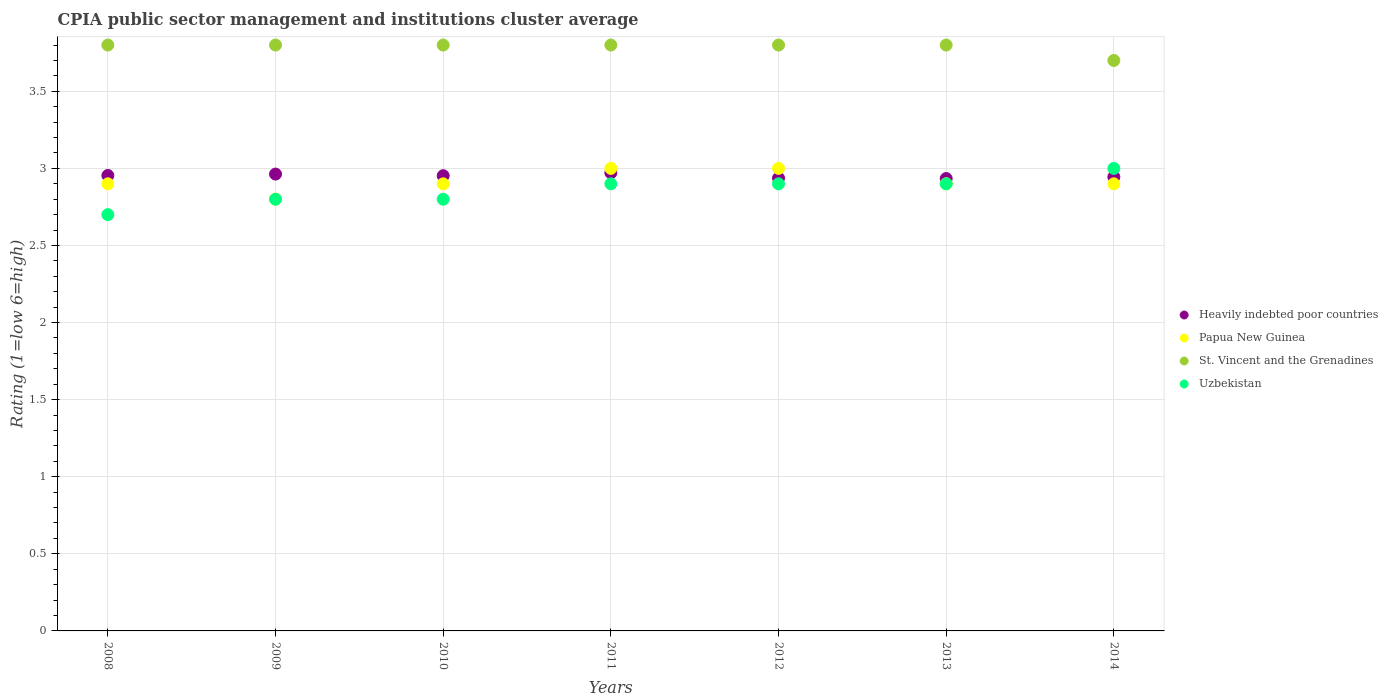Is the number of dotlines equal to the number of legend labels?
Keep it short and to the point. Yes. Across all years, what is the maximum CPIA rating in Heavily indebted poor countries?
Give a very brief answer. 2.97. In which year was the CPIA rating in St. Vincent and the Grenadines minimum?
Provide a short and direct response. 2014. What is the total CPIA rating in Heavily indebted poor countries in the graph?
Make the answer very short. 20.66. What is the difference between the CPIA rating in Heavily indebted poor countries in 2008 and that in 2012?
Provide a succinct answer. 0.02. What is the difference between the CPIA rating in St. Vincent and the Grenadines in 2013 and the CPIA rating in Uzbekistan in 2014?
Offer a very short reply. 0.8. What is the average CPIA rating in Heavily indebted poor countries per year?
Keep it short and to the point. 2.95. In the year 2010, what is the difference between the CPIA rating in Papua New Guinea and CPIA rating in St. Vincent and the Grenadines?
Keep it short and to the point. -0.9. In how many years, is the CPIA rating in Papua New Guinea greater than 2.6?
Offer a terse response. 7. What is the difference between the highest and the second highest CPIA rating in Uzbekistan?
Provide a succinct answer. 0.1. What is the difference between the highest and the lowest CPIA rating in Uzbekistan?
Your answer should be compact. 0.3. In how many years, is the CPIA rating in Heavily indebted poor countries greater than the average CPIA rating in Heavily indebted poor countries taken over all years?
Provide a succinct answer. 4. Is the sum of the CPIA rating in Papua New Guinea in 2008 and 2012 greater than the maximum CPIA rating in Heavily indebted poor countries across all years?
Your answer should be compact. Yes. Is it the case that in every year, the sum of the CPIA rating in Papua New Guinea and CPIA rating in Uzbekistan  is greater than the sum of CPIA rating in Heavily indebted poor countries and CPIA rating in St. Vincent and the Grenadines?
Give a very brief answer. No. Is it the case that in every year, the sum of the CPIA rating in Heavily indebted poor countries and CPIA rating in St. Vincent and the Grenadines  is greater than the CPIA rating in Papua New Guinea?
Your answer should be very brief. Yes. Does the CPIA rating in St. Vincent and the Grenadines monotonically increase over the years?
Provide a succinct answer. No. Is the CPIA rating in Uzbekistan strictly greater than the CPIA rating in St. Vincent and the Grenadines over the years?
Provide a succinct answer. No. What is the difference between two consecutive major ticks on the Y-axis?
Provide a short and direct response. 0.5. Does the graph contain any zero values?
Ensure brevity in your answer.  No. Does the graph contain grids?
Your answer should be very brief. Yes. Where does the legend appear in the graph?
Offer a terse response. Center right. What is the title of the graph?
Your answer should be compact. CPIA public sector management and institutions cluster average. What is the label or title of the X-axis?
Your response must be concise. Years. What is the label or title of the Y-axis?
Keep it short and to the point. Rating (1=low 6=high). What is the Rating (1=low 6=high) in Heavily indebted poor countries in 2008?
Keep it short and to the point. 2.95. What is the Rating (1=low 6=high) in Papua New Guinea in 2008?
Make the answer very short. 2.9. What is the Rating (1=low 6=high) of St. Vincent and the Grenadines in 2008?
Offer a terse response. 3.8. What is the Rating (1=low 6=high) in Heavily indebted poor countries in 2009?
Your answer should be compact. 2.96. What is the Rating (1=low 6=high) of Papua New Guinea in 2009?
Your response must be concise. 2.8. What is the Rating (1=low 6=high) in Uzbekistan in 2009?
Give a very brief answer. 2.8. What is the Rating (1=low 6=high) in Heavily indebted poor countries in 2010?
Offer a very short reply. 2.95. What is the Rating (1=low 6=high) in Papua New Guinea in 2010?
Your response must be concise. 2.9. What is the Rating (1=low 6=high) of St. Vincent and the Grenadines in 2010?
Make the answer very short. 3.8. What is the Rating (1=low 6=high) in Uzbekistan in 2010?
Ensure brevity in your answer.  2.8. What is the Rating (1=low 6=high) in Heavily indebted poor countries in 2011?
Your answer should be compact. 2.97. What is the Rating (1=low 6=high) in Papua New Guinea in 2011?
Keep it short and to the point. 3. What is the Rating (1=low 6=high) of St. Vincent and the Grenadines in 2011?
Make the answer very short. 3.8. What is the Rating (1=low 6=high) of Uzbekistan in 2011?
Offer a terse response. 2.9. What is the Rating (1=low 6=high) of Heavily indebted poor countries in 2012?
Provide a short and direct response. 2.94. What is the Rating (1=low 6=high) in Papua New Guinea in 2012?
Ensure brevity in your answer.  3. What is the Rating (1=low 6=high) of St. Vincent and the Grenadines in 2012?
Your answer should be compact. 3.8. What is the Rating (1=low 6=high) in Heavily indebted poor countries in 2013?
Keep it short and to the point. 2.93. What is the Rating (1=low 6=high) of Heavily indebted poor countries in 2014?
Your response must be concise. 2.94. What is the Rating (1=low 6=high) of Papua New Guinea in 2014?
Ensure brevity in your answer.  2.9. Across all years, what is the maximum Rating (1=low 6=high) of Heavily indebted poor countries?
Your response must be concise. 2.97. Across all years, what is the maximum Rating (1=low 6=high) in St. Vincent and the Grenadines?
Ensure brevity in your answer.  3.8. Across all years, what is the maximum Rating (1=low 6=high) of Uzbekistan?
Offer a very short reply. 3. Across all years, what is the minimum Rating (1=low 6=high) of Heavily indebted poor countries?
Provide a succinct answer. 2.93. Across all years, what is the minimum Rating (1=low 6=high) of St. Vincent and the Grenadines?
Provide a short and direct response. 3.7. Across all years, what is the minimum Rating (1=low 6=high) of Uzbekistan?
Your response must be concise. 2.7. What is the total Rating (1=low 6=high) of Heavily indebted poor countries in the graph?
Your answer should be very brief. 20.66. What is the total Rating (1=low 6=high) in Papua New Guinea in the graph?
Give a very brief answer. 20.4. What is the difference between the Rating (1=low 6=high) in Heavily indebted poor countries in 2008 and that in 2009?
Make the answer very short. -0.01. What is the difference between the Rating (1=low 6=high) of St. Vincent and the Grenadines in 2008 and that in 2009?
Your answer should be very brief. 0. What is the difference between the Rating (1=low 6=high) of Uzbekistan in 2008 and that in 2009?
Provide a short and direct response. -0.1. What is the difference between the Rating (1=low 6=high) of Heavily indebted poor countries in 2008 and that in 2010?
Offer a very short reply. 0. What is the difference between the Rating (1=low 6=high) of Papua New Guinea in 2008 and that in 2010?
Provide a short and direct response. 0. What is the difference between the Rating (1=low 6=high) in Heavily indebted poor countries in 2008 and that in 2011?
Provide a succinct answer. -0.02. What is the difference between the Rating (1=low 6=high) of St. Vincent and the Grenadines in 2008 and that in 2011?
Your answer should be very brief. 0. What is the difference between the Rating (1=low 6=high) of Uzbekistan in 2008 and that in 2011?
Ensure brevity in your answer.  -0.2. What is the difference between the Rating (1=low 6=high) in Heavily indebted poor countries in 2008 and that in 2012?
Your answer should be very brief. 0.02. What is the difference between the Rating (1=low 6=high) of Uzbekistan in 2008 and that in 2012?
Keep it short and to the point. -0.2. What is the difference between the Rating (1=low 6=high) of Heavily indebted poor countries in 2008 and that in 2013?
Your answer should be very brief. 0.02. What is the difference between the Rating (1=low 6=high) of Heavily indebted poor countries in 2008 and that in 2014?
Offer a very short reply. 0.01. What is the difference between the Rating (1=low 6=high) of St. Vincent and the Grenadines in 2008 and that in 2014?
Your response must be concise. 0.1. What is the difference between the Rating (1=low 6=high) of Heavily indebted poor countries in 2009 and that in 2010?
Offer a terse response. 0.01. What is the difference between the Rating (1=low 6=high) in St. Vincent and the Grenadines in 2009 and that in 2010?
Give a very brief answer. 0. What is the difference between the Rating (1=low 6=high) in Heavily indebted poor countries in 2009 and that in 2011?
Provide a succinct answer. -0.01. What is the difference between the Rating (1=low 6=high) in St. Vincent and the Grenadines in 2009 and that in 2011?
Make the answer very short. 0. What is the difference between the Rating (1=low 6=high) in Uzbekistan in 2009 and that in 2011?
Keep it short and to the point. -0.1. What is the difference between the Rating (1=low 6=high) of Heavily indebted poor countries in 2009 and that in 2012?
Keep it short and to the point. 0.03. What is the difference between the Rating (1=low 6=high) in Papua New Guinea in 2009 and that in 2012?
Give a very brief answer. -0.2. What is the difference between the Rating (1=low 6=high) in St. Vincent and the Grenadines in 2009 and that in 2012?
Your response must be concise. 0. What is the difference between the Rating (1=low 6=high) in Heavily indebted poor countries in 2009 and that in 2013?
Your answer should be compact. 0.03. What is the difference between the Rating (1=low 6=high) in Papua New Guinea in 2009 and that in 2013?
Your answer should be very brief. -0.1. What is the difference between the Rating (1=low 6=high) of St. Vincent and the Grenadines in 2009 and that in 2013?
Provide a succinct answer. 0. What is the difference between the Rating (1=low 6=high) of Uzbekistan in 2009 and that in 2013?
Make the answer very short. -0.1. What is the difference between the Rating (1=low 6=high) in Heavily indebted poor countries in 2009 and that in 2014?
Provide a succinct answer. 0.02. What is the difference between the Rating (1=low 6=high) in Heavily indebted poor countries in 2010 and that in 2011?
Offer a terse response. -0.02. What is the difference between the Rating (1=low 6=high) of Uzbekistan in 2010 and that in 2011?
Offer a very short reply. -0.1. What is the difference between the Rating (1=low 6=high) in Heavily indebted poor countries in 2010 and that in 2012?
Your response must be concise. 0.02. What is the difference between the Rating (1=low 6=high) in Papua New Guinea in 2010 and that in 2012?
Ensure brevity in your answer.  -0.1. What is the difference between the Rating (1=low 6=high) of Uzbekistan in 2010 and that in 2012?
Offer a very short reply. -0.1. What is the difference between the Rating (1=low 6=high) in Heavily indebted poor countries in 2010 and that in 2013?
Give a very brief answer. 0.02. What is the difference between the Rating (1=low 6=high) of St. Vincent and the Grenadines in 2010 and that in 2013?
Your answer should be very brief. 0. What is the difference between the Rating (1=low 6=high) in Heavily indebted poor countries in 2010 and that in 2014?
Your answer should be very brief. 0.01. What is the difference between the Rating (1=low 6=high) of Papua New Guinea in 2010 and that in 2014?
Offer a very short reply. 0. What is the difference between the Rating (1=low 6=high) in Heavily indebted poor countries in 2011 and that in 2012?
Ensure brevity in your answer.  0.03. What is the difference between the Rating (1=low 6=high) in St. Vincent and the Grenadines in 2011 and that in 2012?
Your response must be concise. 0. What is the difference between the Rating (1=low 6=high) of Heavily indebted poor countries in 2011 and that in 2013?
Give a very brief answer. 0.04. What is the difference between the Rating (1=low 6=high) of Papua New Guinea in 2011 and that in 2013?
Give a very brief answer. 0.1. What is the difference between the Rating (1=low 6=high) of Uzbekistan in 2011 and that in 2013?
Offer a very short reply. 0. What is the difference between the Rating (1=low 6=high) of Heavily indebted poor countries in 2011 and that in 2014?
Your answer should be very brief. 0.03. What is the difference between the Rating (1=low 6=high) of St. Vincent and the Grenadines in 2011 and that in 2014?
Your answer should be very brief. 0.1. What is the difference between the Rating (1=low 6=high) of Uzbekistan in 2011 and that in 2014?
Your answer should be very brief. -0.1. What is the difference between the Rating (1=low 6=high) in Heavily indebted poor countries in 2012 and that in 2013?
Provide a succinct answer. 0. What is the difference between the Rating (1=low 6=high) in Papua New Guinea in 2012 and that in 2013?
Provide a succinct answer. 0.1. What is the difference between the Rating (1=low 6=high) of St. Vincent and the Grenadines in 2012 and that in 2013?
Offer a very short reply. 0. What is the difference between the Rating (1=low 6=high) in Heavily indebted poor countries in 2012 and that in 2014?
Offer a terse response. -0.01. What is the difference between the Rating (1=low 6=high) of Papua New Guinea in 2012 and that in 2014?
Make the answer very short. 0.1. What is the difference between the Rating (1=low 6=high) of Heavily indebted poor countries in 2013 and that in 2014?
Offer a very short reply. -0.01. What is the difference between the Rating (1=low 6=high) in St. Vincent and the Grenadines in 2013 and that in 2014?
Your response must be concise. 0.1. What is the difference between the Rating (1=low 6=high) in Heavily indebted poor countries in 2008 and the Rating (1=low 6=high) in Papua New Guinea in 2009?
Give a very brief answer. 0.15. What is the difference between the Rating (1=low 6=high) of Heavily indebted poor countries in 2008 and the Rating (1=low 6=high) of St. Vincent and the Grenadines in 2009?
Ensure brevity in your answer.  -0.85. What is the difference between the Rating (1=low 6=high) of Heavily indebted poor countries in 2008 and the Rating (1=low 6=high) of Uzbekistan in 2009?
Keep it short and to the point. 0.15. What is the difference between the Rating (1=low 6=high) of Papua New Guinea in 2008 and the Rating (1=low 6=high) of Uzbekistan in 2009?
Ensure brevity in your answer.  0.1. What is the difference between the Rating (1=low 6=high) in Heavily indebted poor countries in 2008 and the Rating (1=low 6=high) in Papua New Guinea in 2010?
Your answer should be very brief. 0.05. What is the difference between the Rating (1=low 6=high) of Heavily indebted poor countries in 2008 and the Rating (1=low 6=high) of St. Vincent and the Grenadines in 2010?
Make the answer very short. -0.85. What is the difference between the Rating (1=low 6=high) of Heavily indebted poor countries in 2008 and the Rating (1=low 6=high) of Uzbekistan in 2010?
Ensure brevity in your answer.  0.15. What is the difference between the Rating (1=low 6=high) in Papua New Guinea in 2008 and the Rating (1=low 6=high) in St. Vincent and the Grenadines in 2010?
Your answer should be very brief. -0.9. What is the difference between the Rating (1=low 6=high) of Papua New Guinea in 2008 and the Rating (1=low 6=high) of Uzbekistan in 2010?
Provide a short and direct response. 0.1. What is the difference between the Rating (1=low 6=high) of St. Vincent and the Grenadines in 2008 and the Rating (1=low 6=high) of Uzbekistan in 2010?
Ensure brevity in your answer.  1. What is the difference between the Rating (1=low 6=high) in Heavily indebted poor countries in 2008 and the Rating (1=low 6=high) in Papua New Guinea in 2011?
Ensure brevity in your answer.  -0.05. What is the difference between the Rating (1=low 6=high) of Heavily indebted poor countries in 2008 and the Rating (1=low 6=high) of St. Vincent and the Grenadines in 2011?
Provide a short and direct response. -0.85. What is the difference between the Rating (1=low 6=high) in Heavily indebted poor countries in 2008 and the Rating (1=low 6=high) in Uzbekistan in 2011?
Ensure brevity in your answer.  0.05. What is the difference between the Rating (1=low 6=high) in Papua New Guinea in 2008 and the Rating (1=low 6=high) in St. Vincent and the Grenadines in 2011?
Make the answer very short. -0.9. What is the difference between the Rating (1=low 6=high) of St. Vincent and the Grenadines in 2008 and the Rating (1=low 6=high) of Uzbekistan in 2011?
Keep it short and to the point. 0.9. What is the difference between the Rating (1=low 6=high) of Heavily indebted poor countries in 2008 and the Rating (1=low 6=high) of Papua New Guinea in 2012?
Ensure brevity in your answer.  -0.05. What is the difference between the Rating (1=low 6=high) of Heavily indebted poor countries in 2008 and the Rating (1=low 6=high) of St. Vincent and the Grenadines in 2012?
Your answer should be very brief. -0.85. What is the difference between the Rating (1=low 6=high) of Heavily indebted poor countries in 2008 and the Rating (1=low 6=high) of Uzbekistan in 2012?
Offer a terse response. 0.05. What is the difference between the Rating (1=low 6=high) in Papua New Guinea in 2008 and the Rating (1=low 6=high) in St. Vincent and the Grenadines in 2012?
Ensure brevity in your answer.  -0.9. What is the difference between the Rating (1=low 6=high) of Heavily indebted poor countries in 2008 and the Rating (1=low 6=high) of Papua New Guinea in 2013?
Make the answer very short. 0.05. What is the difference between the Rating (1=low 6=high) of Heavily indebted poor countries in 2008 and the Rating (1=low 6=high) of St. Vincent and the Grenadines in 2013?
Your response must be concise. -0.85. What is the difference between the Rating (1=low 6=high) in Heavily indebted poor countries in 2008 and the Rating (1=low 6=high) in Uzbekistan in 2013?
Provide a succinct answer. 0.05. What is the difference between the Rating (1=low 6=high) of St. Vincent and the Grenadines in 2008 and the Rating (1=low 6=high) of Uzbekistan in 2013?
Keep it short and to the point. 0.9. What is the difference between the Rating (1=low 6=high) of Heavily indebted poor countries in 2008 and the Rating (1=low 6=high) of Papua New Guinea in 2014?
Give a very brief answer. 0.05. What is the difference between the Rating (1=low 6=high) of Heavily indebted poor countries in 2008 and the Rating (1=low 6=high) of St. Vincent and the Grenadines in 2014?
Offer a terse response. -0.75. What is the difference between the Rating (1=low 6=high) of Heavily indebted poor countries in 2008 and the Rating (1=low 6=high) of Uzbekistan in 2014?
Your answer should be very brief. -0.05. What is the difference between the Rating (1=low 6=high) in St. Vincent and the Grenadines in 2008 and the Rating (1=low 6=high) in Uzbekistan in 2014?
Ensure brevity in your answer.  0.8. What is the difference between the Rating (1=low 6=high) of Heavily indebted poor countries in 2009 and the Rating (1=low 6=high) of Papua New Guinea in 2010?
Offer a terse response. 0.06. What is the difference between the Rating (1=low 6=high) of Heavily indebted poor countries in 2009 and the Rating (1=low 6=high) of St. Vincent and the Grenadines in 2010?
Provide a succinct answer. -0.84. What is the difference between the Rating (1=low 6=high) of Heavily indebted poor countries in 2009 and the Rating (1=low 6=high) of Uzbekistan in 2010?
Offer a very short reply. 0.16. What is the difference between the Rating (1=low 6=high) of Papua New Guinea in 2009 and the Rating (1=low 6=high) of St. Vincent and the Grenadines in 2010?
Ensure brevity in your answer.  -1. What is the difference between the Rating (1=low 6=high) in Papua New Guinea in 2009 and the Rating (1=low 6=high) in Uzbekistan in 2010?
Offer a terse response. 0. What is the difference between the Rating (1=low 6=high) in Heavily indebted poor countries in 2009 and the Rating (1=low 6=high) in Papua New Guinea in 2011?
Give a very brief answer. -0.04. What is the difference between the Rating (1=low 6=high) in Heavily indebted poor countries in 2009 and the Rating (1=low 6=high) in St. Vincent and the Grenadines in 2011?
Provide a short and direct response. -0.84. What is the difference between the Rating (1=low 6=high) of Heavily indebted poor countries in 2009 and the Rating (1=low 6=high) of Uzbekistan in 2011?
Offer a very short reply. 0.06. What is the difference between the Rating (1=low 6=high) of St. Vincent and the Grenadines in 2009 and the Rating (1=low 6=high) of Uzbekistan in 2011?
Give a very brief answer. 0.9. What is the difference between the Rating (1=low 6=high) of Heavily indebted poor countries in 2009 and the Rating (1=low 6=high) of Papua New Guinea in 2012?
Make the answer very short. -0.04. What is the difference between the Rating (1=low 6=high) of Heavily indebted poor countries in 2009 and the Rating (1=low 6=high) of St. Vincent and the Grenadines in 2012?
Your response must be concise. -0.84. What is the difference between the Rating (1=low 6=high) in Heavily indebted poor countries in 2009 and the Rating (1=low 6=high) in Uzbekistan in 2012?
Offer a very short reply. 0.06. What is the difference between the Rating (1=low 6=high) in Papua New Guinea in 2009 and the Rating (1=low 6=high) in St. Vincent and the Grenadines in 2012?
Offer a terse response. -1. What is the difference between the Rating (1=low 6=high) of Papua New Guinea in 2009 and the Rating (1=low 6=high) of Uzbekistan in 2012?
Your response must be concise. -0.1. What is the difference between the Rating (1=low 6=high) in St. Vincent and the Grenadines in 2009 and the Rating (1=low 6=high) in Uzbekistan in 2012?
Ensure brevity in your answer.  0.9. What is the difference between the Rating (1=low 6=high) of Heavily indebted poor countries in 2009 and the Rating (1=low 6=high) of Papua New Guinea in 2013?
Give a very brief answer. 0.06. What is the difference between the Rating (1=low 6=high) of Heavily indebted poor countries in 2009 and the Rating (1=low 6=high) of St. Vincent and the Grenadines in 2013?
Provide a succinct answer. -0.84. What is the difference between the Rating (1=low 6=high) in Heavily indebted poor countries in 2009 and the Rating (1=low 6=high) in Uzbekistan in 2013?
Provide a short and direct response. 0.06. What is the difference between the Rating (1=low 6=high) of Papua New Guinea in 2009 and the Rating (1=low 6=high) of Uzbekistan in 2013?
Provide a succinct answer. -0.1. What is the difference between the Rating (1=low 6=high) in Heavily indebted poor countries in 2009 and the Rating (1=low 6=high) in Papua New Guinea in 2014?
Provide a succinct answer. 0.06. What is the difference between the Rating (1=low 6=high) of Heavily indebted poor countries in 2009 and the Rating (1=low 6=high) of St. Vincent and the Grenadines in 2014?
Offer a terse response. -0.74. What is the difference between the Rating (1=low 6=high) of Heavily indebted poor countries in 2009 and the Rating (1=low 6=high) of Uzbekistan in 2014?
Ensure brevity in your answer.  -0.04. What is the difference between the Rating (1=low 6=high) in St. Vincent and the Grenadines in 2009 and the Rating (1=low 6=high) in Uzbekistan in 2014?
Provide a succinct answer. 0.8. What is the difference between the Rating (1=low 6=high) of Heavily indebted poor countries in 2010 and the Rating (1=low 6=high) of Papua New Guinea in 2011?
Provide a succinct answer. -0.05. What is the difference between the Rating (1=low 6=high) of Heavily indebted poor countries in 2010 and the Rating (1=low 6=high) of St. Vincent and the Grenadines in 2011?
Ensure brevity in your answer.  -0.85. What is the difference between the Rating (1=low 6=high) in Heavily indebted poor countries in 2010 and the Rating (1=low 6=high) in Uzbekistan in 2011?
Offer a very short reply. 0.05. What is the difference between the Rating (1=low 6=high) in Heavily indebted poor countries in 2010 and the Rating (1=low 6=high) in Papua New Guinea in 2012?
Make the answer very short. -0.05. What is the difference between the Rating (1=low 6=high) in Heavily indebted poor countries in 2010 and the Rating (1=low 6=high) in St. Vincent and the Grenadines in 2012?
Provide a short and direct response. -0.85. What is the difference between the Rating (1=low 6=high) of Heavily indebted poor countries in 2010 and the Rating (1=low 6=high) of Uzbekistan in 2012?
Offer a very short reply. 0.05. What is the difference between the Rating (1=low 6=high) of St. Vincent and the Grenadines in 2010 and the Rating (1=low 6=high) of Uzbekistan in 2012?
Your response must be concise. 0.9. What is the difference between the Rating (1=low 6=high) in Heavily indebted poor countries in 2010 and the Rating (1=low 6=high) in Papua New Guinea in 2013?
Offer a terse response. 0.05. What is the difference between the Rating (1=low 6=high) of Heavily indebted poor countries in 2010 and the Rating (1=low 6=high) of St. Vincent and the Grenadines in 2013?
Your response must be concise. -0.85. What is the difference between the Rating (1=low 6=high) in Heavily indebted poor countries in 2010 and the Rating (1=low 6=high) in Uzbekistan in 2013?
Give a very brief answer. 0.05. What is the difference between the Rating (1=low 6=high) in St. Vincent and the Grenadines in 2010 and the Rating (1=low 6=high) in Uzbekistan in 2013?
Provide a short and direct response. 0.9. What is the difference between the Rating (1=low 6=high) of Heavily indebted poor countries in 2010 and the Rating (1=low 6=high) of Papua New Guinea in 2014?
Offer a very short reply. 0.05. What is the difference between the Rating (1=low 6=high) in Heavily indebted poor countries in 2010 and the Rating (1=low 6=high) in St. Vincent and the Grenadines in 2014?
Make the answer very short. -0.75. What is the difference between the Rating (1=low 6=high) of Heavily indebted poor countries in 2010 and the Rating (1=low 6=high) of Uzbekistan in 2014?
Your answer should be very brief. -0.05. What is the difference between the Rating (1=low 6=high) of Papua New Guinea in 2010 and the Rating (1=low 6=high) of St. Vincent and the Grenadines in 2014?
Your answer should be very brief. -0.8. What is the difference between the Rating (1=low 6=high) in Papua New Guinea in 2010 and the Rating (1=low 6=high) in Uzbekistan in 2014?
Your answer should be very brief. -0.1. What is the difference between the Rating (1=low 6=high) of St. Vincent and the Grenadines in 2010 and the Rating (1=low 6=high) of Uzbekistan in 2014?
Provide a succinct answer. 0.8. What is the difference between the Rating (1=low 6=high) of Heavily indebted poor countries in 2011 and the Rating (1=low 6=high) of Papua New Guinea in 2012?
Give a very brief answer. -0.03. What is the difference between the Rating (1=low 6=high) of Heavily indebted poor countries in 2011 and the Rating (1=low 6=high) of St. Vincent and the Grenadines in 2012?
Offer a very short reply. -0.83. What is the difference between the Rating (1=low 6=high) in Heavily indebted poor countries in 2011 and the Rating (1=low 6=high) in Uzbekistan in 2012?
Offer a terse response. 0.07. What is the difference between the Rating (1=low 6=high) in Papua New Guinea in 2011 and the Rating (1=low 6=high) in St. Vincent and the Grenadines in 2012?
Make the answer very short. -0.8. What is the difference between the Rating (1=low 6=high) of Papua New Guinea in 2011 and the Rating (1=low 6=high) of Uzbekistan in 2012?
Give a very brief answer. 0.1. What is the difference between the Rating (1=low 6=high) in Heavily indebted poor countries in 2011 and the Rating (1=low 6=high) in Papua New Guinea in 2013?
Keep it short and to the point. 0.07. What is the difference between the Rating (1=low 6=high) in Heavily indebted poor countries in 2011 and the Rating (1=low 6=high) in St. Vincent and the Grenadines in 2013?
Give a very brief answer. -0.83. What is the difference between the Rating (1=low 6=high) of Heavily indebted poor countries in 2011 and the Rating (1=low 6=high) of Uzbekistan in 2013?
Offer a very short reply. 0.07. What is the difference between the Rating (1=low 6=high) of St. Vincent and the Grenadines in 2011 and the Rating (1=low 6=high) of Uzbekistan in 2013?
Provide a succinct answer. 0.9. What is the difference between the Rating (1=low 6=high) of Heavily indebted poor countries in 2011 and the Rating (1=low 6=high) of Papua New Guinea in 2014?
Your answer should be compact. 0.07. What is the difference between the Rating (1=low 6=high) of Heavily indebted poor countries in 2011 and the Rating (1=low 6=high) of St. Vincent and the Grenadines in 2014?
Ensure brevity in your answer.  -0.73. What is the difference between the Rating (1=low 6=high) in Heavily indebted poor countries in 2011 and the Rating (1=low 6=high) in Uzbekistan in 2014?
Your answer should be very brief. -0.03. What is the difference between the Rating (1=low 6=high) in Papua New Guinea in 2011 and the Rating (1=low 6=high) in St. Vincent and the Grenadines in 2014?
Your answer should be compact. -0.7. What is the difference between the Rating (1=low 6=high) in Papua New Guinea in 2011 and the Rating (1=low 6=high) in Uzbekistan in 2014?
Provide a short and direct response. 0. What is the difference between the Rating (1=low 6=high) of Heavily indebted poor countries in 2012 and the Rating (1=low 6=high) of Papua New Guinea in 2013?
Provide a succinct answer. 0.04. What is the difference between the Rating (1=low 6=high) in Heavily indebted poor countries in 2012 and the Rating (1=low 6=high) in St. Vincent and the Grenadines in 2013?
Give a very brief answer. -0.86. What is the difference between the Rating (1=low 6=high) of Heavily indebted poor countries in 2012 and the Rating (1=low 6=high) of Uzbekistan in 2013?
Your response must be concise. 0.04. What is the difference between the Rating (1=low 6=high) of Heavily indebted poor countries in 2012 and the Rating (1=low 6=high) of Papua New Guinea in 2014?
Your answer should be very brief. 0.04. What is the difference between the Rating (1=low 6=high) in Heavily indebted poor countries in 2012 and the Rating (1=low 6=high) in St. Vincent and the Grenadines in 2014?
Provide a succinct answer. -0.76. What is the difference between the Rating (1=low 6=high) in Heavily indebted poor countries in 2012 and the Rating (1=low 6=high) in Uzbekistan in 2014?
Keep it short and to the point. -0.06. What is the difference between the Rating (1=low 6=high) of Papua New Guinea in 2012 and the Rating (1=low 6=high) of St. Vincent and the Grenadines in 2014?
Ensure brevity in your answer.  -0.7. What is the difference between the Rating (1=low 6=high) in Heavily indebted poor countries in 2013 and the Rating (1=low 6=high) in Papua New Guinea in 2014?
Keep it short and to the point. 0.03. What is the difference between the Rating (1=low 6=high) of Heavily indebted poor countries in 2013 and the Rating (1=low 6=high) of St. Vincent and the Grenadines in 2014?
Give a very brief answer. -0.77. What is the difference between the Rating (1=low 6=high) in Heavily indebted poor countries in 2013 and the Rating (1=low 6=high) in Uzbekistan in 2014?
Offer a very short reply. -0.07. What is the difference between the Rating (1=low 6=high) of Papua New Guinea in 2013 and the Rating (1=low 6=high) of Uzbekistan in 2014?
Offer a very short reply. -0.1. What is the difference between the Rating (1=low 6=high) in St. Vincent and the Grenadines in 2013 and the Rating (1=low 6=high) in Uzbekistan in 2014?
Offer a terse response. 0.8. What is the average Rating (1=low 6=high) of Heavily indebted poor countries per year?
Your answer should be compact. 2.95. What is the average Rating (1=low 6=high) of Papua New Guinea per year?
Your answer should be compact. 2.91. What is the average Rating (1=low 6=high) of St. Vincent and the Grenadines per year?
Provide a short and direct response. 3.79. What is the average Rating (1=low 6=high) in Uzbekistan per year?
Keep it short and to the point. 2.86. In the year 2008, what is the difference between the Rating (1=low 6=high) in Heavily indebted poor countries and Rating (1=low 6=high) in Papua New Guinea?
Your answer should be very brief. 0.05. In the year 2008, what is the difference between the Rating (1=low 6=high) in Heavily indebted poor countries and Rating (1=low 6=high) in St. Vincent and the Grenadines?
Offer a very short reply. -0.85. In the year 2008, what is the difference between the Rating (1=low 6=high) in Heavily indebted poor countries and Rating (1=low 6=high) in Uzbekistan?
Offer a very short reply. 0.25. In the year 2008, what is the difference between the Rating (1=low 6=high) of Papua New Guinea and Rating (1=low 6=high) of St. Vincent and the Grenadines?
Provide a short and direct response. -0.9. In the year 2008, what is the difference between the Rating (1=low 6=high) in St. Vincent and the Grenadines and Rating (1=low 6=high) in Uzbekistan?
Ensure brevity in your answer.  1.1. In the year 2009, what is the difference between the Rating (1=low 6=high) in Heavily indebted poor countries and Rating (1=low 6=high) in Papua New Guinea?
Keep it short and to the point. 0.16. In the year 2009, what is the difference between the Rating (1=low 6=high) in Heavily indebted poor countries and Rating (1=low 6=high) in St. Vincent and the Grenadines?
Ensure brevity in your answer.  -0.84. In the year 2009, what is the difference between the Rating (1=low 6=high) of Heavily indebted poor countries and Rating (1=low 6=high) of Uzbekistan?
Keep it short and to the point. 0.16. In the year 2009, what is the difference between the Rating (1=low 6=high) in Papua New Guinea and Rating (1=low 6=high) in St. Vincent and the Grenadines?
Offer a terse response. -1. In the year 2010, what is the difference between the Rating (1=low 6=high) of Heavily indebted poor countries and Rating (1=low 6=high) of Papua New Guinea?
Keep it short and to the point. 0.05. In the year 2010, what is the difference between the Rating (1=low 6=high) of Heavily indebted poor countries and Rating (1=low 6=high) of St. Vincent and the Grenadines?
Your answer should be very brief. -0.85. In the year 2010, what is the difference between the Rating (1=low 6=high) of Heavily indebted poor countries and Rating (1=low 6=high) of Uzbekistan?
Keep it short and to the point. 0.15. In the year 2010, what is the difference between the Rating (1=low 6=high) in Papua New Guinea and Rating (1=low 6=high) in Uzbekistan?
Your answer should be very brief. 0.1. In the year 2010, what is the difference between the Rating (1=low 6=high) in St. Vincent and the Grenadines and Rating (1=low 6=high) in Uzbekistan?
Your answer should be very brief. 1. In the year 2011, what is the difference between the Rating (1=low 6=high) of Heavily indebted poor countries and Rating (1=low 6=high) of Papua New Guinea?
Your response must be concise. -0.03. In the year 2011, what is the difference between the Rating (1=low 6=high) in Heavily indebted poor countries and Rating (1=low 6=high) in St. Vincent and the Grenadines?
Give a very brief answer. -0.83. In the year 2011, what is the difference between the Rating (1=low 6=high) in Heavily indebted poor countries and Rating (1=low 6=high) in Uzbekistan?
Ensure brevity in your answer.  0.07. In the year 2011, what is the difference between the Rating (1=low 6=high) of Papua New Guinea and Rating (1=low 6=high) of St. Vincent and the Grenadines?
Ensure brevity in your answer.  -0.8. In the year 2011, what is the difference between the Rating (1=low 6=high) of Papua New Guinea and Rating (1=low 6=high) of Uzbekistan?
Give a very brief answer. 0.1. In the year 2011, what is the difference between the Rating (1=low 6=high) in St. Vincent and the Grenadines and Rating (1=low 6=high) in Uzbekistan?
Ensure brevity in your answer.  0.9. In the year 2012, what is the difference between the Rating (1=low 6=high) of Heavily indebted poor countries and Rating (1=low 6=high) of Papua New Guinea?
Keep it short and to the point. -0.06. In the year 2012, what is the difference between the Rating (1=low 6=high) of Heavily indebted poor countries and Rating (1=low 6=high) of St. Vincent and the Grenadines?
Your response must be concise. -0.86. In the year 2012, what is the difference between the Rating (1=low 6=high) in Heavily indebted poor countries and Rating (1=low 6=high) in Uzbekistan?
Provide a succinct answer. 0.04. In the year 2012, what is the difference between the Rating (1=low 6=high) in Papua New Guinea and Rating (1=low 6=high) in Uzbekistan?
Provide a short and direct response. 0.1. In the year 2013, what is the difference between the Rating (1=low 6=high) in Heavily indebted poor countries and Rating (1=low 6=high) in Papua New Guinea?
Make the answer very short. 0.03. In the year 2013, what is the difference between the Rating (1=low 6=high) in Heavily indebted poor countries and Rating (1=low 6=high) in St. Vincent and the Grenadines?
Your response must be concise. -0.87. In the year 2013, what is the difference between the Rating (1=low 6=high) in Heavily indebted poor countries and Rating (1=low 6=high) in Uzbekistan?
Ensure brevity in your answer.  0.03. In the year 2013, what is the difference between the Rating (1=low 6=high) in Papua New Guinea and Rating (1=low 6=high) in St. Vincent and the Grenadines?
Your answer should be very brief. -0.9. In the year 2013, what is the difference between the Rating (1=low 6=high) of St. Vincent and the Grenadines and Rating (1=low 6=high) of Uzbekistan?
Ensure brevity in your answer.  0.9. In the year 2014, what is the difference between the Rating (1=low 6=high) of Heavily indebted poor countries and Rating (1=low 6=high) of Papua New Guinea?
Your response must be concise. 0.04. In the year 2014, what is the difference between the Rating (1=low 6=high) in Heavily indebted poor countries and Rating (1=low 6=high) in St. Vincent and the Grenadines?
Your answer should be compact. -0.76. In the year 2014, what is the difference between the Rating (1=low 6=high) of Heavily indebted poor countries and Rating (1=low 6=high) of Uzbekistan?
Your response must be concise. -0.06. In the year 2014, what is the difference between the Rating (1=low 6=high) of Papua New Guinea and Rating (1=low 6=high) of St. Vincent and the Grenadines?
Keep it short and to the point. -0.8. What is the ratio of the Rating (1=low 6=high) in Papua New Guinea in 2008 to that in 2009?
Provide a short and direct response. 1.04. What is the ratio of the Rating (1=low 6=high) in Uzbekistan in 2008 to that in 2009?
Your response must be concise. 0.96. What is the ratio of the Rating (1=low 6=high) in Heavily indebted poor countries in 2008 to that in 2010?
Your response must be concise. 1. What is the ratio of the Rating (1=low 6=high) in Papua New Guinea in 2008 to that in 2010?
Provide a short and direct response. 1. What is the ratio of the Rating (1=low 6=high) in Uzbekistan in 2008 to that in 2010?
Offer a terse response. 0.96. What is the ratio of the Rating (1=low 6=high) in Papua New Guinea in 2008 to that in 2011?
Provide a short and direct response. 0.97. What is the ratio of the Rating (1=low 6=high) in Heavily indebted poor countries in 2008 to that in 2012?
Keep it short and to the point. 1.01. What is the ratio of the Rating (1=low 6=high) in Papua New Guinea in 2008 to that in 2012?
Your answer should be very brief. 0.97. What is the ratio of the Rating (1=low 6=high) of Uzbekistan in 2008 to that in 2012?
Your answer should be compact. 0.93. What is the ratio of the Rating (1=low 6=high) of Heavily indebted poor countries in 2008 to that in 2013?
Offer a very short reply. 1.01. What is the ratio of the Rating (1=low 6=high) in Papua New Guinea in 2008 to that in 2013?
Provide a short and direct response. 1. What is the ratio of the Rating (1=low 6=high) in Uzbekistan in 2008 to that in 2013?
Your answer should be compact. 0.93. What is the ratio of the Rating (1=low 6=high) in Heavily indebted poor countries in 2008 to that in 2014?
Provide a succinct answer. 1. What is the ratio of the Rating (1=low 6=high) of Uzbekistan in 2008 to that in 2014?
Provide a succinct answer. 0.9. What is the ratio of the Rating (1=low 6=high) in Papua New Guinea in 2009 to that in 2010?
Keep it short and to the point. 0.97. What is the ratio of the Rating (1=low 6=high) in St. Vincent and the Grenadines in 2009 to that in 2010?
Ensure brevity in your answer.  1. What is the ratio of the Rating (1=low 6=high) of Uzbekistan in 2009 to that in 2011?
Keep it short and to the point. 0.97. What is the ratio of the Rating (1=low 6=high) of Heavily indebted poor countries in 2009 to that in 2012?
Your answer should be very brief. 1.01. What is the ratio of the Rating (1=low 6=high) in Uzbekistan in 2009 to that in 2012?
Keep it short and to the point. 0.97. What is the ratio of the Rating (1=low 6=high) in Heavily indebted poor countries in 2009 to that in 2013?
Provide a succinct answer. 1.01. What is the ratio of the Rating (1=low 6=high) of Papua New Guinea in 2009 to that in 2013?
Offer a very short reply. 0.97. What is the ratio of the Rating (1=low 6=high) in St. Vincent and the Grenadines in 2009 to that in 2013?
Your answer should be very brief. 1. What is the ratio of the Rating (1=low 6=high) in Uzbekistan in 2009 to that in 2013?
Provide a succinct answer. 0.97. What is the ratio of the Rating (1=low 6=high) in Heavily indebted poor countries in 2009 to that in 2014?
Your answer should be very brief. 1.01. What is the ratio of the Rating (1=low 6=high) in Papua New Guinea in 2009 to that in 2014?
Your response must be concise. 0.97. What is the ratio of the Rating (1=low 6=high) in St. Vincent and the Grenadines in 2009 to that in 2014?
Provide a succinct answer. 1.03. What is the ratio of the Rating (1=low 6=high) of Uzbekistan in 2009 to that in 2014?
Offer a very short reply. 0.93. What is the ratio of the Rating (1=low 6=high) in Heavily indebted poor countries in 2010 to that in 2011?
Provide a short and direct response. 0.99. What is the ratio of the Rating (1=low 6=high) of Papua New Guinea in 2010 to that in 2011?
Offer a very short reply. 0.97. What is the ratio of the Rating (1=low 6=high) in St. Vincent and the Grenadines in 2010 to that in 2011?
Give a very brief answer. 1. What is the ratio of the Rating (1=low 6=high) in Uzbekistan in 2010 to that in 2011?
Your response must be concise. 0.97. What is the ratio of the Rating (1=low 6=high) of Heavily indebted poor countries in 2010 to that in 2012?
Your answer should be very brief. 1.01. What is the ratio of the Rating (1=low 6=high) in Papua New Guinea in 2010 to that in 2012?
Make the answer very short. 0.97. What is the ratio of the Rating (1=low 6=high) of Uzbekistan in 2010 to that in 2012?
Keep it short and to the point. 0.97. What is the ratio of the Rating (1=low 6=high) of Heavily indebted poor countries in 2010 to that in 2013?
Provide a short and direct response. 1.01. What is the ratio of the Rating (1=low 6=high) of St. Vincent and the Grenadines in 2010 to that in 2013?
Provide a succinct answer. 1. What is the ratio of the Rating (1=low 6=high) in Uzbekistan in 2010 to that in 2013?
Your response must be concise. 0.97. What is the ratio of the Rating (1=low 6=high) in Papua New Guinea in 2010 to that in 2014?
Your answer should be very brief. 1. What is the ratio of the Rating (1=low 6=high) of Heavily indebted poor countries in 2011 to that in 2012?
Keep it short and to the point. 1.01. What is the ratio of the Rating (1=low 6=high) of Papua New Guinea in 2011 to that in 2012?
Offer a terse response. 1. What is the ratio of the Rating (1=low 6=high) of St. Vincent and the Grenadines in 2011 to that in 2012?
Offer a terse response. 1. What is the ratio of the Rating (1=low 6=high) of Heavily indebted poor countries in 2011 to that in 2013?
Provide a short and direct response. 1.01. What is the ratio of the Rating (1=low 6=high) in Papua New Guinea in 2011 to that in 2013?
Give a very brief answer. 1.03. What is the ratio of the Rating (1=low 6=high) of Uzbekistan in 2011 to that in 2013?
Your response must be concise. 1. What is the ratio of the Rating (1=low 6=high) in Heavily indebted poor countries in 2011 to that in 2014?
Provide a short and direct response. 1.01. What is the ratio of the Rating (1=low 6=high) of Papua New Guinea in 2011 to that in 2014?
Your response must be concise. 1.03. What is the ratio of the Rating (1=low 6=high) in Uzbekistan in 2011 to that in 2014?
Make the answer very short. 0.97. What is the ratio of the Rating (1=low 6=high) in Papua New Guinea in 2012 to that in 2013?
Your response must be concise. 1.03. What is the ratio of the Rating (1=low 6=high) of Uzbekistan in 2012 to that in 2013?
Offer a very short reply. 1. What is the ratio of the Rating (1=low 6=high) of Heavily indebted poor countries in 2012 to that in 2014?
Offer a very short reply. 1. What is the ratio of the Rating (1=low 6=high) in Papua New Guinea in 2012 to that in 2014?
Make the answer very short. 1.03. What is the ratio of the Rating (1=low 6=high) of Uzbekistan in 2012 to that in 2014?
Ensure brevity in your answer.  0.97. What is the ratio of the Rating (1=low 6=high) in Heavily indebted poor countries in 2013 to that in 2014?
Ensure brevity in your answer.  1. What is the ratio of the Rating (1=low 6=high) of Papua New Guinea in 2013 to that in 2014?
Ensure brevity in your answer.  1. What is the ratio of the Rating (1=low 6=high) of St. Vincent and the Grenadines in 2013 to that in 2014?
Keep it short and to the point. 1.03. What is the ratio of the Rating (1=low 6=high) in Uzbekistan in 2013 to that in 2014?
Keep it short and to the point. 0.97. What is the difference between the highest and the second highest Rating (1=low 6=high) in Heavily indebted poor countries?
Keep it short and to the point. 0.01. What is the difference between the highest and the second highest Rating (1=low 6=high) of Papua New Guinea?
Give a very brief answer. 0. What is the difference between the highest and the second highest Rating (1=low 6=high) in St. Vincent and the Grenadines?
Provide a succinct answer. 0. What is the difference between the highest and the lowest Rating (1=low 6=high) of Heavily indebted poor countries?
Keep it short and to the point. 0.04. What is the difference between the highest and the lowest Rating (1=low 6=high) in Papua New Guinea?
Keep it short and to the point. 0.2. What is the difference between the highest and the lowest Rating (1=low 6=high) in St. Vincent and the Grenadines?
Provide a short and direct response. 0.1. What is the difference between the highest and the lowest Rating (1=low 6=high) of Uzbekistan?
Your response must be concise. 0.3. 